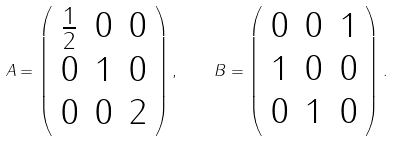Convert formula to latex. <formula><loc_0><loc_0><loc_500><loc_500>A = \left ( \begin{array} { c c c } \frac { 1 } { 2 } & 0 & 0 \\ 0 & 1 & 0 \\ 0 & 0 & 2 \end{array} \right ) , \quad B = \left ( \begin{array} { c c c } 0 & 0 & 1 \\ 1 & 0 & 0 \\ 0 & 1 & 0 \end{array} \right ) .</formula> 